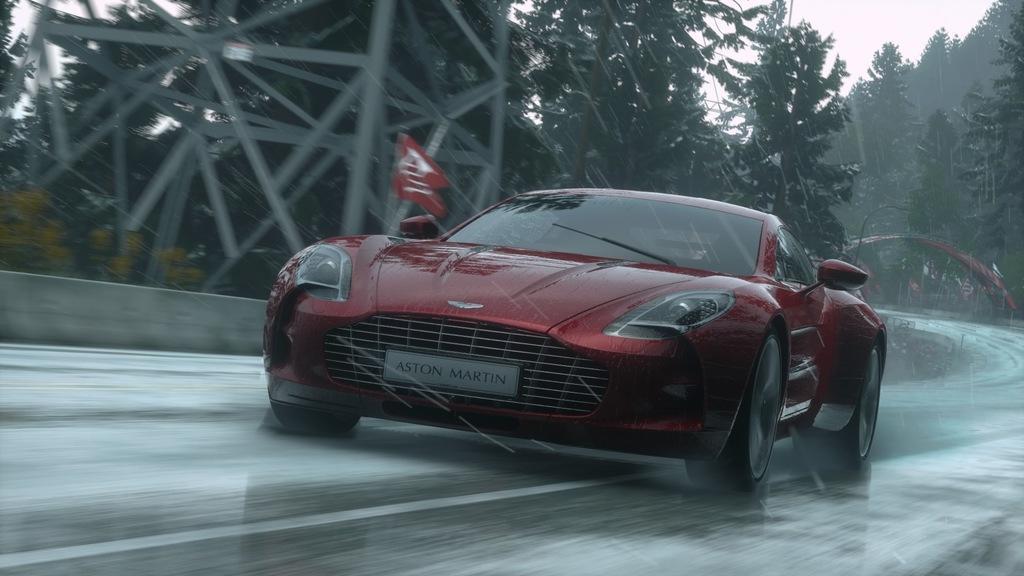In one or two sentences, can you explain what this image depicts? In this picture we can see a red car on the road. There is a red flag on this car. It is raining. We can see few trees and a tower on the left side. There are some flags in the background. 